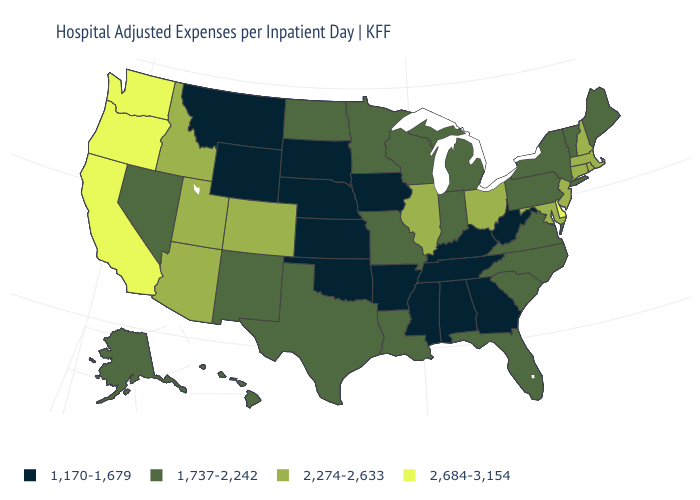What is the value of North Dakota?
Be succinct. 1,737-2,242. What is the value of Colorado?
Be succinct. 2,274-2,633. What is the highest value in the MidWest ?
Write a very short answer. 2,274-2,633. What is the value of Virginia?
Write a very short answer. 1,737-2,242. Among the states that border Wyoming , which have the highest value?
Short answer required. Colorado, Idaho, Utah. Does Delaware have the highest value in the South?
Keep it brief. Yes. What is the value of Oregon?
Be succinct. 2,684-3,154. Among the states that border Iowa , does Wisconsin have the lowest value?
Concise answer only. No. How many symbols are there in the legend?
Be succinct. 4. Which states hav the highest value in the Northeast?
Write a very short answer. Connecticut, Massachusetts, New Hampshire, New Jersey, Rhode Island. What is the lowest value in states that border Wyoming?
Write a very short answer. 1,170-1,679. What is the lowest value in the USA?
Be succinct. 1,170-1,679. Which states have the highest value in the USA?
Be succinct. California, Delaware, Oregon, Washington. Which states have the lowest value in the West?
Give a very brief answer. Montana, Wyoming. 